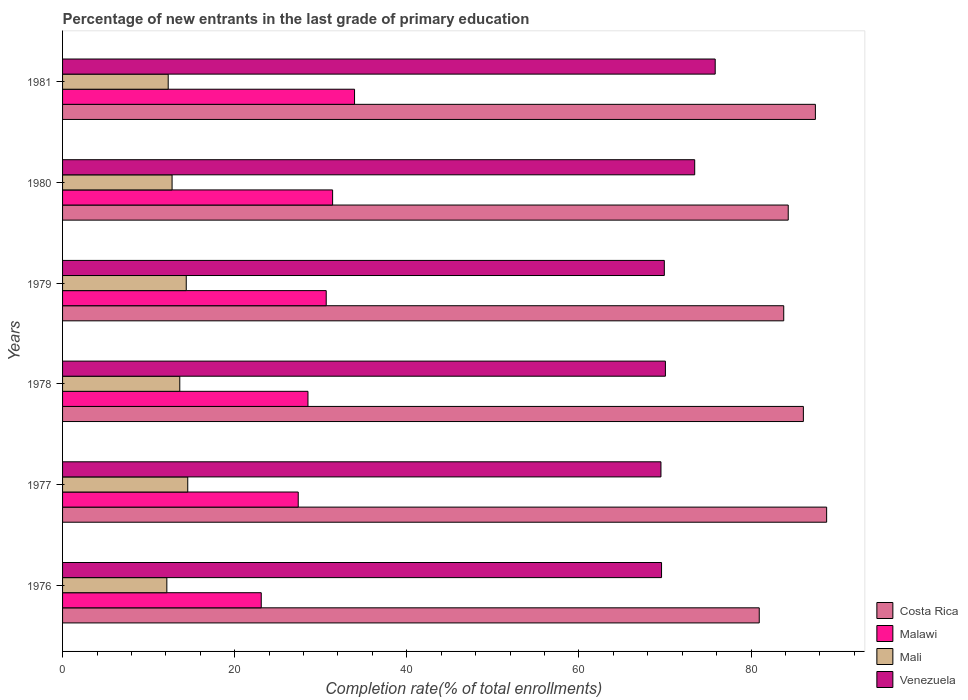How many groups of bars are there?
Offer a very short reply. 6. Are the number of bars on each tick of the Y-axis equal?
Provide a succinct answer. Yes. How many bars are there on the 2nd tick from the top?
Make the answer very short. 4. How many bars are there on the 4th tick from the bottom?
Your response must be concise. 4. What is the percentage of new entrants in Venezuela in 1981?
Offer a terse response. 75.83. Across all years, what is the maximum percentage of new entrants in Costa Rica?
Offer a very short reply. 88.77. Across all years, what is the minimum percentage of new entrants in Venezuela?
Ensure brevity in your answer.  69.52. In which year was the percentage of new entrants in Venezuela minimum?
Make the answer very short. 1977. What is the total percentage of new entrants in Costa Rica in the graph?
Offer a very short reply. 511.35. What is the difference between the percentage of new entrants in Mali in 1978 and that in 1979?
Your answer should be compact. -0.75. What is the difference between the percentage of new entrants in Malawi in 1980 and the percentage of new entrants in Mali in 1978?
Give a very brief answer. 17.76. What is the average percentage of new entrants in Malawi per year?
Provide a short and direct response. 29.15. In the year 1980, what is the difference between the percentage of new entrants in Costa Rica and percentage of new entrants in Malawi?
Your answer should be compact. 52.94. In how many years, is the percentage of new entrants in Mali greater than 48 %?
Provide a succinct answer. 0. What is the ratio of the percentage of new entrants in Mali in 1979 to that in 1980?
Keep it short and to the point. 1.13. What is the difference between the highest and the second highest percentage of new entrants in Venezuela?
Provide a short and direct response. 2.38. What is the difference between the highest and the lowest percentage of new entrants in Malawi?
Ensure brevity in your answer.  10.84. In how many years, is the percentage of new entrants in Costa Rica greater than the average percentage of new entrants in Costa Rica taken over all years?
Give a very brief answer. 3. Is the sum of the percentage of new entrants in Mali in 1977 and 1978 greater than the maximum percentage of new entrants in Venezuela across all years?
Your response must be concise. No. Is it the case that in every year, the sum of the percentage of new entrants in Venezuela and percentage of new entrants in Malawi is greater than the sum of percentage of new entrants in Mali and percentage of new entrants in Costa Rica?
Your response must be concise. Yes. What does the 3rd bar from the top in 1976 represents?
Offer a terse response. Malawi. What does the 3rd bar from the bottom in 1976 represents?
Provide a short and direct response. Mali. Is it the case that in every year, the sum of the percentage of new entrants in Costa Rica and percentage of new entrants in Malawi is greater than the percentage of new entrants in Mali?
Your answer should be compact. Yes. How many years are there in the graph?
Provide a succinct answer. 6. Are the values on the major ticks of X-axis written in scientific E-notation?
Your answer should be compact. No. Does the graph contain any zero values?
Your answer should be compact. No. How are the legend labels stacked?
Give a very brief answer. Vertical. What is the title of the graph?
Your answer should be very brief. Percentage of new entrants in the last grade of primary education. What is the label or title of the X-axis?
Give a very brief answer. Completion rate(% of total enrollments). What is the Completion rate(% of total enrollments) in Costa Rica in 1976?
Provide a short and direct response. 80.94. What is the Completion rate(% of total enrollments) of Malawi in 1976?
Provide a short and direct response. 23.08. What is the Completion rate(% of total enrollments) of Mali in 1976?
Give a very brief answer. 12.12. What is the Completion rate(% of total enrollments) in Venezuela in 1976?
Your response must be concise. 69.59. What is the Completion rate(% of total enrollments) of Costa Rica in 1977?
Your answer should be compact. 88.77. What is the Completion rate(% of total enrollments) of Malawi in 1977?
Provide a short and direct response. 27.38. What is the Completion rate(% of total enrollments) in Mali in 1977?
Offer a terse response. 14.55. What is the Completion rate(% of total enrollments) of Venezuela in 1977?
Your answer should be very brief. 69.52. What is the Completion rate(% of total enrollments) of Costa Rica in 1978?
Provide a succinct answer. 86.07. What is the Completion rate(% of total enrollments) in Malawi in 1978?
Offer a very short reply. 28.51. What is the Completion rate(% of total enrollments) of Mali in 1978?
Offer a very short reply. 13.62. What is the Completion rate(% of total enrollments) of Venezuela in 1978?
Your response must be concise. 70.04. What is the Completion rate(% of total enrollments) in Costa Rica in 1979?
Make the answer very short. 83.79. What is the Completion rate(% of total enrollments) of Malawi in 1979?
Your answer should be compact. 30.63. What is the Completion rate(% of total enrollments) in Mali in 1979?
Offer a terse response. 14.37. What is the Completion rate(% of total enrollments) in Venezuela in 1979?
Offer a very short reply. 69.91. What is the Completion rate(% of total enrollments) in Costa Rica in 1980?
Provide a short and direct response. 84.31. What is the Completion rate(% of total enrollments) of Malawi in 1980?
Give a very brief answer. 31.37. What is the Completion rate(% of total enrollments) in Mali in 1980?
Your answer should be compact. 12.72. What is the Completion rate(% of total enrollments) in Venezuela in 1980?
Make the answer very short. 73.44. What is the Completion rate(% of total enrollments) in Costa Rica in 1981?
Make the answer very short. 87.47. What is the Completion rate(% of total enrollments) in Malawi in 1981?
Offer a terse response. 33.92. What is the Completion rate(% of total enrollments) of Mali in 1981?
Offer a terse response. 12.27. What is the Completion rate(% of total enrollments) in Venezuela in 1981?
Make the answer very short. 75.83. Across all years, what is the maximum Completion rate(% of total enrollments) of Costa Rica?
Your answer should be very brief. 88.77. Across all years, what is the maximum Completion rate(% of total enrollments) of Malawi?
Make the answer very short. 33.92. Across all years, what is the maximum Completion rate(% of total enrollments) of Mali?
Provide a short and direct response. 14.55. Across all years, what is the maximum Completion rate(% of total enrollments) of Venezuela?
Offer a terse response. 75.83. Across all years, what is the minimum Completion rate(% of total enrollments) in Costa Rica?
Your answer should be very brief. 80.94. Across all years, what is the minimum Completion rate(% of total enrollments) of Malawi?
Your response must be concise. 23.08. Across all years, what is the minimum Completion rate(% of total enrollments) in Mali?
Give a very brief answer. 12.12. Across all years, what is the minimum Completion rate(% of total enrollments) of Venezuela?
Make the answer very short. 69.52. What is the total Completion rate(% of total enrollments) in Costa Rica in the graph?
Your response must be concise. 511.35. What is the total Completion rate(% of total enrollments) in Malawi in the graph?
Offer a very short reply. 174.91. What is the total Completion rate(% of total enrollments) of Mali in the graph?
Keep it short and to the point. 79.64. What is the total Completion rate(% of total enrollments) in Venezuela in the graph?
Ensure brevity in your answer.  428.34. What is the difference between the Completion rate(% of total enrollments) of Costa Rica in 1976 and that in 1977?
Keep it short and to the point. -7.83. What is the difference between the Completion rate(% of total enrollments) of Malawi in 1976 and that in 1977?
Make the answer very short. -4.3. What is the difference between the Completion rate(% of total enrollments) of Mali in 1976 and that in 1977?
Your answer should be compact. -2.43. What is the difference between the Completion rate(% of total enrollments) of Venezuela in 1976 and that in 1977?
Provide a succinct answer. 0.07. What is the difference between the Completion rate(% of total enrollments) in Costa Rica in 1976 and that in 1978?
Provide a short and direct response. -5.13. What is the difference between the Completion rate(% of total enrollments) in Malawi in 1976 and that in 1978?
Keep it short and to the point. -5.43. What is the difference between the Completion rate(% of total enrollments) of Mali in 1976 and that in 1978?
Your answer should be very brief. -1.5. What is the difference between the Completion rate(% of total enrollments) in Venezuela in 1976 and that in 1978?
Provide a short and direct response. -0.45. What is the difference between the Completion rate(% of total enrollments) of Costa Rica in 1976 and that in 1979?
Your answer should be compact. -2.85. What is the difference between the Completion rate(% of total enrollments) in Malawi in 1976 and that in 1979?
Make the answer very short. -7.55. What is the difference between the Completion rate(% of total enrollments) of Mali in 1976 and that in 1979?
Offer a very short reply. -2.25. What is the difference between the Completion rate(% of total enrollments) in Venezuela in 1976 and that in 1979?
Your answer should be very brief. -0.32. What is the difference between the Completion rate(% of total enrollments) in Costa Rica in 1976 and that in 1980?
Provide a short and direct response. -3.37. What is the difference between the Completion rate(% of total enrollments) in Malawi in 1976 and that in 1980?
Ensure brevity in your answer.  -8.29. What is the difference between the Completion rate(% of total enrollments) in Mali in 1976 and that in 1980?
Give a very brief answer. -0.61. What is the difference between the Completion rate(% of total enrollments) in Venezuela in 1976 and that in 1980?
Give a very brief answer. -3.85. What is the difference between the Completion rate(% of total enrollments) in Costa Rica in 1976 and that in 1981?
Make the answer very short. -6.52. What is the difference between the Completion rate(% of total enrollments) in Malawi in 1976 and that in 1981?
Your answer should be compact. -10.84. What is the difference between the Completion rate(% of total enrollments) in Mali in 1976 and that in 1981?
Your answer should be compact. -0.16. What is the difference between the Completion rate(% of total enrollments) of Venezuela in 1976 and that in 1981?
Keep it short and to the point. -6.23. What is the difference between the Completion rate(% of total enrollments) of Costa Rica in 1977 and that in 1978?
Keep it short and to the point. 2.7. What is the difference between the Completion rate(% of total enrollments) in Malawi in 1977 and that in 1978?
Your answer should be compact. -1.13. What is the difference between the Completion rate(% of total enrollments) in Mali in 1977 and that in 1978?
Your response must be concise. 0.93. What is the difference between the Completion rate(% of total enrollments) of Venezuela in 1977 and that in 1978?
Offer a very short reply. -0.52. What is the difference between the Completion rate(% of total enrollments) in Costa Rica in 1977 and that in 1979?
Provide a short and direct response. 4.99. What is the difference between the Completion rate(% of total enrollments) in Malawi in 1977 and that in 1979?
Keep it short and to the point. -3.25. What is the difference between the Completion rate(% of total enrollments) in Mali in 1977 and that in 1979?
Your answer should be compact. 0.18. What is the difference between the Completion rate(% of total enrollments) in Venezuela in 1977 and that in 1979?
Provide a succinct answer. -0.39. What is the difference between the Completion rate(% of total enrollments) of Costa Rica in 1977 and that in 1980?
Offer a very short reply. 4.46. What is the difference between the Completion rate(% of total enrollments) in Malawi in 1977 and that in 1980?
Ensure brevity in your answer.  -3.99. What is the difference between the Completion rate(% of total enrollments) of Mali in 1977 and that in 1980?
Provide a short and direct response. 1.82. What is the difference between the Completion rate(% of total enrollments) in Venezuela in 1977 and that in 1980?
Keep it short and to the point. -3.92. What is the difference between the Completion rate(% of total enrollments) of Costa Rica in 1977 and that in 1981?
Make the answer very short. 1.31. What is the difference between the Completion rate(% of total enrollments) of Malawi in 1977 and that in 1981?
Offer a very short reply. -6.54. What is the difference between the Completion rate(% of total enrollments) of Mali in 1977 and that in 1981?
Your answer should be compact. 2.27. What is the difference between the Completion rate(% of total enrollments) of Venezuela in 1977 and that in 1981?
Your response must be concise. -6.3. What is the difference between the Completion rate(% of total enrollments) in Costa Rica in 1978 and that in 1979?
Keep it short and to the point. 2.28. What is the difference between the Completion rate(% of total enrollments) in Malawi in 1978 and that in 1979?
Ensure brevity in your answer.  -2.12. What is the difference between the Completion rate(% of total enrollments) in Mali in 1978 and that in 1979?
Ensure brevity in your answer.  -0.75. What is the difference between the Completion rate(% of total enrollments) in Venezuela in 1978 and that in 1979?
Your answer should be compact. 0.12. What is the difference between the Completion rate(% of total enrollments) in Costa Rica in 1978 and that in 1980?
Make the answer very short. 1.76. What is the difference between the Completion rate(% of total enrollments) in Malawi in 1978 and that in 1980?
Your response must be concise. -2.86. What is the difference between the Completion rate(% of total enrollments) of Mali in 1978 and that in 1980?
Offer a very short reply. 0.9. What is the difference between the Completion rate(% of total enrollments) of Venezuela in 1978 and that in 1980?
Your answer should be very brief. -3.4. What is the difference between the Completion rate(% of total enrollments) in Costa Rica in 1978 and that in 1981?
Offer a terse response. -1.4. What is the difference between the Completion rate(% of total enrollments) of Malawi in 1978 and that in 1981?
Give a very brief answer. -5.41. What is the difference between the Completion rate(% of total enrollments) in Mali in 1978 and that in 1981?
Give a very brief answer. 1.35. What is the difference between the Completion rate(% of total enrollments) in Venezuela in 1978 and that in 1981?
Ensure brevity in your answer.  -5.79. What is the difference between the Completion rate(% of total enrollments) in Costa Rica in 1979 and that in 1980?
Offer a terse response. -0.52. What is the difference between the Completion rate(% of total enrollments) of Malawi in 1979 and that in 1980?
Offer a terse response. -0.74. What is the difference between the Completion rate(% of total enrollments) in Mali in 1979 and that in 1980?
Make the answer very short. 1.65. What is the difference between the Completion rate(% of total enrollments) in Venezuela in 1979 and that in 1980?
Provide a short and direct response. -3.53. What is the difference between the Completion rate(% of total enrollments) of Costa Rica in 1979 and that in 1981?
Offer a terse response. -3.68. What is the difference between the Completion rate(% of total enrollments) in Malawi in 1979 and that in 1981?
Ensure brevity in your answer.  -3.29. What is the difference between the Completion rate(% of total enrollments) of Mali in 1979 and that in 1981?
Offer a terse response. 2.1. What is the difference between the Completion rate(% of total enrollments) of Venezuela in 1979 and that in 1981?
Provide a short and direct response. -5.91. What is the difference between the Completion rate(% of total enrollments) in Costa Rica in 1980 and that in 1981?
Offer a terse response. -3.16. What is the difference between the Completion rate(% of total enrollments) of Malawi in 1980 and that in 1981?
Keep it short and to the point. -2.55. What is the difference between the Completion rate(% of total enrollments) in Mali in 1980 and that in 1981?
Offer a very short reply. 0.45. What is the difference between the Completion rate(% of total enrollments) in Venezuela in 1980 and that in 1981?
Give a very brief answer. -2.38. What is the difference between the Completion rate(% of total enrollments) of Costa Rica in 1976 and the Completion rate(% of total enrollments) of Malawi in 1977?
Provide a succinct answer. 53.56. What is the difference between the Completion rate(% of total enrollments) of Costa Rica in 1976 and the Completion rate(% of total enrollments) of Mali in 1977?
Offer a terse response. 66.4. What is the difference between the Completion rate(% of total enrollments) of Costa Rica in 1976 and the Completion rate(% of total enrollments) of Venezuela in 1977?
Ensure brevity in your answer.  11.42. What is the difference between the Completion rate(% of total enrollments) in Malawi in 1976 and the Completion rate(% of total enrollments) in Mali in 1977?
Your response must be concise. 8.54. What is the difference between the Completion rate(% of total enrollments) in Malawi in 1976 and the Completion rate(% of total enrollments) in Venezuela in 1977?
Your response must be concise. -46.44. What is the difference between the Completion rate(% of total enrollments) in Mali in 1976 and the Completion rate(% of total enrollments) in Venezuela in 1977?
Provide a short and direct response. -57.41. What is the difference between the Completion rate(% of total enrollments) of Costa Rica in 1976 and the Completion rate(% of total enrollments) of Malawi in 1978?
Your answer should be compact. 52.43. What is the difference between the Completion rate(% of total enrollments) in Costa Rica in 1976 and the Completion rate(% of total enrollments) in Mali in 1978?
Your answer should be very brief. 67.32. What is the difference between the Completion rate(% of total enrollments) of Costa Rica in 1976 and the Completion rate(% of total enrollments) of Venezuela in 1978?
Make the answer very short. 10.9. What is the difference between the Completion rate(% of total enrollments) of Malawi in 1976 and the Completion rate(% of total enrollments) of Mali in 1978?
Make the answer very short. 9.46. What is the difference between the Completion rate(% of total enrollments) in Malawi in 1976 and the Completion rate(% of total enrollments) in Venezuela in 1978?
Provide a succinct answer. -46.96. What is the difference between the Completion rate(% of total enrollments) of Mali in 1976 and the Completion rate(% of total enrollments) of Venezuela in 1978?
Your answer should be very brief. -57.92. What is the difference between the Completion rate(% of total enrollments) of Costa Rica in 1976 and the Completion rate(% of total enrollments) of Malawi in 1979?
Provide a short and direct response. 50.31. What is the difference between the Completion rate(% of total enrollments) of Costa Rica in 1976 and the Completion rate(% of total enrollments) of Mali in 1979?
Offer a terse response. 66.57. What is the difference between the Completion rate(% of total enrollments) in Costa Rica in 1976 and the Completion rate(% of total enrollments) in Venezuela in 1979?
Provide a succinct answer. 11.03. What is the difference between the Completion rate(% of total enrollments) in Malawi in 1976 and the Completion rate(% of total enrollments) in Mali in 1979?
Offer a very short reply. 8.71. What is the difference between the Completion rate(% of total enrollments) of Malawi in 1976 and the Completion rate(% of total enrollments) of Venezuela in 1979?
Ensure brevity in your answer.  -46.83. What is the difference between the Completion rate(% of total enrollments) of Mali in 1976 and the Completion rate(% of total enrollments) of Venezuela in 1979?
Provide a short and direct response. -57.8. What is the difference between the Completion rate(% of total enrollments) of Costa Rica in 1976 and the Completion rate(% of total enrollments) of Malawi in 1980?
Keep it short and to the point. 49.57. What is the difference between the Completion rate(% of total enrollments) of Costa Rica in 1976 and the Completion rate(% of total enrollments) of Mali in 1980?
Offer a very short reply. 68.22. What is the difference between the Completion rate(% of total enrollments) of Costa Rica in 1976 and the Completion rate(% of total enrollments) of Venezuela in 1980?
Keep it short and to the point. 7.5. What is the difference between the Completion rate(% of total enrollments) of Malawi in 1976 and the Completion rate(% of total enrollments) of Mali in 1980?
Give a very brief answer. 10.36. What is the difference between the Completion rate(% of total enrollments) in Malawi in 1976 and the Completion rate(% of total enrollments) in Venezuela in 1980?
Make the answer very short. -50.36. What is the difference between the Completion rate(% of total enrollments) of Mali in 1976 and the Completion rate(% of total enrollments) of Venezuela in 1980?
Keep it short and to the point. -61.33. What is the difference between the Completion rate(% of total enrollments) in Costa Rica in 1976 and the Completion rate(% of total enrollments) in Malawi in 1981?
Offer a very short reply. 47.02. What is the difference between the Completion rate(% of total enrollments) of Costa Rica in 1976 and the Completion rate(% of total enrollments) of Mali in 1981?
Offer a very short reply. 68.67. What is the difference between the Completion rate(% of total enrollments) of Costa Rica in 1976 and the Completion rate(% of total enrollments) of Venezuela in 1981?
Make the answer very short. 5.12. What is the difference between the Completion rate(% of total enrollments) of Malawi in 1976 and the Completion rate(% of total enrollments) of Mali in 1981?
Provide a short and direct response. 10.81. What is the difference between the Completion rate(% of total enrollments) in Malawi in 1976 and the Completion rate(% of total enrollments) in Venezuela in 1981?
Your answer should be compact. -52.74. What is the difference between the Completion rate(% of total enrollments) in Mali in 1976 and the Completion rate(% of total enrollments) in Venezuela in 1981?
Offer a terse response. -63.71. What is the difference between the Completion rate(% of total enrollments) in Costa Rica in 1977 and the Completion rate(% of total enrollments) in Malawi in 1978?
Offer a terse response. 60.26. What is the difference between the Completion rate(% of total enrollments) in Costa Rica in 1977 and the Completion rate(% of total enrollments) in Mali in 1978?
Provide a succinct answer. 75.16. What is the difference between the Completion rate(% of total enrollments) of Costa Rica in 1977 and the Completion rate(% of total enrollments) of Venezuela in 1978?
Offer a terse response. 18.73. What is the difference between the Completion rate(% of total enrollments) in Malawi in 1977 and the Completion rate(% of total enrollments) in Mali in 1978?
Offer a very short reply. 13.76. What is the difference between the Completion rate(% of total enrollments) in Malawi in 1977 and the Completion rate(% of total enrollments) in Venezuela in 1978?
Ensure brevity in your answer.  -42.66. What is the difference between the Completion rate(% of total enrollments) in Mali in 1977 and the Completion rate(% of total enrollments) in Venezuela in 1978?
Make the answer very short. -55.49. What is the difference between the Completion rate(% of total enrollments) of Costa Rica in 1977 and the Completion rate(% of total enrollments) of Malawi in 1979?
Your answer should be very brief. 58.14. What is the difference between the Completion rate(% of total enrollments) of Costa Rica in 1977 and the Completion rate(% of total enrollments) of Mali in 1979?
Give a very brief answer. 74.4. What is the difference between the Completion rate(% of total enrollments) of Costa Rica in 1977 and the Completion rate(% of total enrollments) of Venezuela in 1979?
Offer a terse response. 18.86. What is the difference between the Completion rate(% of total enrollments) in Malawi in 1977 and the Completion rate(% of total enrollments) in Mali in 1979?
Give a very brief answer. 13.01. What is the difference between the Completion rate(% of total enrollments) of Malawi in 1977 and the Completion rate(% of total enrollments) of Venezuela in 1979?
Your response must be concise. -42.53. What is the difference between the Completion rate(% of total enrollments) of Mali in 1977 and the Completion rate(% of total enrollments) of Venezuela in 1979?
Make the answer very short. -55.37. What is the difference between the Completion rate(% of total enrollments) of Costa Rica in 1977 and the Completion rate(% of total enrollments) of Malawi in 1980?
Your response must be concise. 57.4. What is the difference between the Completion rate(% of total enrollments) of Costa Rica in 1977 and the Completion rate(% of total enrollments) of Mali in 1980?
Make the answer very short. 76.05. What is the difference between the Completion rate(% of total enrollments) in Costa Rica in 1977 and the Completion rate(% of total enrollments) in Venezuela in 1980?
Offer a terse response. 15.33. What is the difference between the Completion rate(% of total enrollments) of Malawi in 1977 and the Completion rate(% of total enrollments) of Mali in 1980?
Ensure brevity in your answer.  14.66. What is the difference between the Completion rate(% of total enrollments) in Malawi in 1977 and the Completion rate(% of total enrollments) in Venezuela in 1980?
Provide a short and direct response. -46.06. What is the difference between the Completion rate(% of total enrollments) in Mali in 1977 and the Completion rate(% of total enrollments) in Venezuela in 1980?
Your response must be concise. -58.9. What is the difference between the Completion rate(% of total enrollments) of Costa Rica in 1977 and the Completion rate(% of total enrollments) of Malawi in 1981?
Your answer should be very brief. 54.85. What is the difference between the Completion rate(% of total enrollments) of Costa Rica in 1977 and the Completion rate(% of total enrollments) of Mali in 1981?
Keep it short and to the point. 76.5. What is the difference between the Completion rate(% of total enrollments) in Costa Rica in 1977 and the Completion rate(% of total enrollments) in Venezuela in 1981?
Ensure brevity in your answer.  12.95. What is the difference between the Completion rate(% of total enrollments) of Malawi in 1977 and the Completion rate(% of total enrollments) of Mali in 1981?
Provide a short and direct response. 15.11. What is the difference between the Completion rate(% of total enrollments) in Malawi in 1977 and the Completion rate(% of total enrollments) in Venezuela in 1981?
Give a very brief answer. -48.44. What is the difference between the Completion rate(% of total enrollments) in Mali in 1977 and the Completion rate(% of total enrollments) in Venezuela in 1981?
Provide a short and direct response. -61.28. What is the difference between the Completion rate(% of total enrollments) of Costa Rica in 1978 and the Completion rate(% of total enrollments) of Malawi in 1979?
Offer a terse response. 55.44. What is the difference between the Completion rate(% of total enrollments) of Costa Rica in 1978 and the Completion rate(% of total enrollments) of Mali in 1979?
Provide a short and direct response. 71.7. What is the difference between the Completion rate(% of total enrollments) in Costa Rica in 1978 and the Completion rate(% of total enrollments) in Venezuela in 1979?
Keep it short and to the point. 16.16. What is the difference between the Completion rate(% of total enrollments) in Malawi in 1978 and the Completion rate(% of total enrollments) in Mali in 1979?
Offer a terse response. 14.14. What is the difference between the Completion rate(% of total enrollments) in Malawi in 1978 and the Completion rate(% of total enrollments) in Venezuela in 1979?
Keep it short and to the point. -41.4. What is the difference between the Completion rate(% of total enrollments) of Mali in 1978 and the Completion rate(% of total enrollments) of Venezuela in 1979?
Your answer should be compact. -56.3. What is the difference between the Completion rate(% of total enrollments) of Costa Rica in 1978 and the Completion rate(% of total enrollments) of Malawi in 1980?
Provide a short and direct response. 54.7. What is the difference between the Completion rate(% of total enrollments) in Costa Rica in 1978 and the Completion rate(% of total enrollments) in Mali in 1980?
Give a very brief answer. 73.35. What is the difference between the Completion rate(% of total enrollments) in Costa Rica in 1978 and the Completion rate(% of total enrollments) in Venezuela in 1980?
Ensure brevity in your answer.  12.63. What is the difference between the Completion rate(% of total enrollments) of Malawi in 1978 and the Completion rate(% of total enrollments) of Mali in 1980?
Your answer should be very brief. 15.79. What is the difference between the Completion rate(% of total enrollments) in Malawi in 1978 and the Completion rate(% of total enrollments) in Venezuela in 1980?
Offer a terse response. -44.93. What is the difference between the Completion rate(% of total enrollments) in Mali in 1978 and the Completion rate(% of total enrollments) in Venezuela in 1980?
Offer a terse response. -59.83. What is the difference between the Completion rate(% of total enrollments) in Costa Rica in 1978 and the Completion rate(% of total enrollments) in Malawi in 1981?
Give a very brief answer. 52.15. What is the difference between the Completion rate(% of total enrollments) of Costa Rica in 1978 and the Completion rate(% of total enrollments) of Mali in 1981?
Make the answer very short. 73.8. What is the difference between the Completion rate(% of total enrollments) in Costa Rica in 1978 and the Completion rate(% of total enrollments) in Venezuela in 1981?
Provide a succinct answer. 10.24. What is the difference between the Completion rate(% of total enrollments) of Malawi in 1978 and the Completion rate(% of total enrollments) of Mali in 1981?
Keep it short and to the point. 16.24. What is the difference between the Completion rate(% of total enrollments) in Malawi in 1978 and the Completion rate(% of total enrollments) in Venezuela in 1981?
Your answer should be compact. -47.31. What is the difference between the Completion rate(% of total enrollments) of Mali in 1978 and the Completion rate(% of total enrollments) of Venezuela in 1981?
Your answer should be very brief. -62.21. What is the difference between the Completion rate(% of total enrollments) in Costa Rica in 1979 and the Completion rate(% of total enrollments) in Malawi in 1980?
Give a very brief answer. 52.41. What is the difference between the Completion rate(% of total enrollments) in Costa Rica in 1979 and the Completion rate(% of total enrollments) in Mali in 1980?
Make the answer very short. 71.07. What is the difference between the Completion rate(% of total enrollments) of Costa Rica in 1979 and the Completion rate(% of total enrollments) of Venezuela in 1980?
Give a very brief answer. 10.34. What is the difference between the Completion rate(% of total enrollments) of Malawi in 1979 and the Completion rate(% of total enrollments) of Mali in 1980?
Keep it short and to the point. 17.91. What is the difference between the Completion rate(% of total enrollments) of Malawi in 1979 and the Completion rate(% of total enrollments) of Venezuela in 1980?
Provide a succinct answer. -42.81. What is the difference between the Completion rate(% of total enrollments) of Mali in 1979 and the Completion rate(% of total enrollments) of Venezuela in 1980?
Give a very brief answer. -59.07. What is the difference between the Completion rate(% of total enrollments) of Costa Rica in 1979 and the Completion rate(% of total enrollments) of Malawi in 1981?
Offer a very short reply. 49.86. What is the difference between the Completion rate(% of total enrollments) in Costa Rica in 1979 and the Completion rate(% of total enrollments) in Mali in 1981?
Your answer should be compact. 71.52. What is the difference between the Completion rate(% of total enrollments) of Costa Rica in 1979 and the Completion rate(% of total enrollments) of Venezuela in 1981?
Give a very brief answer. 7.96. What is the difference between the Completion rate(% of total enrollments) of Malawi in 1979 and the Completion rate(% of total enrollments) of Mali in 1981?
Offer a terse response. 18.36. What is the difference between the Completion rate(% of total enrollments) in Malawi in 1979 and the Completion rate(% of total enrollments) in Venezuela in 1981?
Offer a terse response. -45.19. What is the difference between the Completion rate(% of total enrollments) in Mali in 1979 and the Completion rate(% of total enrollments) in Venezuela in 1981?
Your answer should be very brief. -61.46. What is the difference between the Completion rate(% of total enrollments) of Costa Rica in 1980 and the Completion rate(% of total enrollments) of Malawi in 1981?
Your answer should be very brief. 50.39. What is the difference between the Completion rate(% of total enrollments) of Costa Rica in 1980 and the Completion rate(% of total enrollments) of Mali in 1981?
Offer a terse response. 72.04. What is the difference between the Completion rate(% of total enrollments) of Costa Rica in 1980 and the Completion rate(% of total enrollments) of Venezuela in 1981?
Give a very brief answer. 8.48. What is the difference between the Completion rate(% of total enrollments) of Malawi in 1980 and the Completion rate(% of total enrollments) of Mali in 1981?
Give a very brief answer. 19.1. What is the difference between the Completion rate(% of total enrollments) in Malawi in 1980 and the Completion rate(% of total enrollments) in Venezuela in 1981?
Your answer should be compact. -44.45. What is the difference between the Completion rate(% of total enrollments) of Mali in 1980 and the Completion rate(% of total enrollments) of Venezuela in 1981?
Provide a succinct answer. -63.1. What is the average Completion rate(% of total enrollments) in Costa Rica per year?
Your response must be concise. 85.23. What is the average Completion rate(% of total enrollments) in Malawi per year?
Your answer should be very brief. 29.15. What is the average Completion rate(% of total enrollments) of Mali per year?
Ensure brevity in your answer.  13.27. What is the average Completion rate(% of total enrollments) in Venezuela per year?
Keep it short and to the point. 71.39. In the year 1976, what is the difference between the Completion rate(% of total enrollments) of Costa Rica and Completion rate(% of total enrollments) of Malawi?
Offer a terse response. 57.86. In the year 1976, what is the difference between the Completion rate(% of total enrollments) in Costa Rica and Completion rate(% of total enrollments) in Mali?
Your answer should be very brief. 68.83. In the year 1976, what is the difference between the Completion rate(% of total enrollments) of Costa Rica and Completion rate(% of total enrollments) of Venezuela?
Your answer should be very brief. 11.35. In the year 1976, what is the difference between the Completion rate(% of total enrollments) of Malawi and Completion rate(% of total enrollments) of Mali?
Keep it short and to the point. 10.97. In the year 1976, what is the difference between the Completion rate(% of total enrollments) in Malawi and Completion rate(% of total enrollments) in Venezuela?
Provide a short and direct response. -46.51. In the year 1976, what is the difference between the Completion rate(% of total enrollments) of Mali and Completion rate(% of total enrollments) of Venezuela?
Ensure brevity in your answer.  -57.48. In the year 1977, what is the difference between the Completion rate(% of total enrollments) in Costa Rica and Completion rate(% of total enrollments) in Malawi?
Your answer should be very brief. 61.39. In the year 1977, what is the difference between the Completion rate(% of total enrollments) in Costa Rica and Completion rate(% of total enrollments) in Mali?
Offer a terse response. 74.23. In the year 1977, what is the difference between the Completion rate(% of total enrollments) of Costa Rica and Completion rate(% of total enrollments) of Venezuela?
Keep it short and to the point. 19.25. In the year 1977, what is the difference between the Completion rate(% of total enrollments) of Malawi and Completion rate(% of total enrollments) of Mali?
Your answer should be very brief. 12.84. In the year 1977, what is the difference between the Completion rate(% of total enrollments) of Malawi and Completion rate(% of total enrollments) of Venezuela?
Keep it short and to the point. -42.14. In the year 1977, what is the difference between the Completion rate(% of total enrollments) of Mali and Completion rate(% of total enrollments) of Venezuela?
Ensure brevity in your answer.  -54.98. In the year 1978, what is the difference between the Completion rate(% of total enrollments) of Costa Rica and Completion rate(% of total enrollments) of Malawi?
Your response must be concise. 57.56. In the year 1978, what is the difference between the Completion rate(% of total enrollments) of Costa Rica and Completion rate(% of total enrollments) of Mali?
Provide a succinct answer. 72.45. In the year 1978, what is the difference between the Completion rate(% of total enrollments) of Costa Rica and Completion rate(% of total enrollments) of Venezuela?
Your response must be concise. 16.03. In the year 1978, what is the difference between the Completion rate(% of total enrollments) in Malawi and Completion rate(% of total enrollments) in Mali?
Your answer should be very brief. 14.89. In the year 1978, what is the difference between the Completion rate(% of total enrollments) in Malawi and Completion rate(% of total enrollments) in Venezuela?
Your response must be concise. -41.53. In the year 1978, what is the difference between the Completion rate(% of total enrollments) in Mali and Completion rate(% of total enrollments) in Venezuela?
Give a very brief answer. -56.42. In the year 1979, what is the difference between the Completion rate(% of total enrollments) in Costa Rica and Completion rate(% of total enrollments) in Malawi?
Your response must be concise. 53.16. In the year 1979, what is the difference between the Completion rate(% of total enrollments) of Costa Rica and Completion rate(% of total enrollments) of Mali?
Provide a short and direct response. 69.42. In the year 1979, what is the difference between the Completion rate(% of total enrollments) of Costa Rica and Completion rate(% of total enrollments) of Venezuela?
Provide a succinct answer. 13.87. In the year 1979, what is the difference between the Completion rate(% of total enrollments) of Malawi and Completion rate(% of total enrollments) of Mali?
Keep it short and to the point. 16.26. In the year 1979, what is the difference between the Completion rate(% of total enrollments) of Malawi and Completion rate(% of total enrollments) of Venezuela?
Provide a short and direct response. -39.28. In the year 1979, what is the difference between the Completion rate(% of total enrollments) in Mali and Completion rate(% of total enrollments) in Venezuela?
Your response must be concise. -55.55. In the year 1980, what is the difference between the Completion rate(% of total enrollments) in Costa Rica and Completion rate(% of total enrollments) in Malawi?
Offer a very short reply. 52.94. In the year 1980, what is the difference between the Completion rate(% of total enrollments) of Costa Rica and Completion rate(% of total enrollments) of Mali?
Provide a short and direct response. 71.59. In the year 1980, what is the difference between the Completion rate(% of total enrollments) in Costa Rica and Completion rate(% of total enrollments) in Venezuela?
Ensure brevity in your answer.  10.87. In the year 1980, what is the difference between the Completion rate(% of total enrollments) of Malawi and Completion rate(% of total enrollments) of Mali?
Provide a succinct answer. 18.65. In the year 1980, what is the difference between the Completion rate(% of total enrollments) in Malawi and Completion rate(% of total enrollments) in Venezuela?
Provide a succinct answer. -42.07. In the year 1980, what is the difference between the Completion rate(% of total enrollments) in Mali and Completion rate(% of total enrollments) in Venezuela?
Provide a succinct answer. -60.72. In the year 1981, what is the difference between the Completion rate(% of total enrollments) of Costa Rica and Completion rate(% of total enrollments) of Malawi?
Offer a terse response. 53.54. In the year 1981, what is the difference between the Completion rate(% of total enrollments) of Costa Rica and Completion rate(% of total enrollments) of Mali?
Make the answer very short. 75.19. In the year 1981, what is the difference between the Completion rate(% of total enrollments) in Costa Rica and Completion rate(% of total enrollments) in Venezuela?
Provide a succinct answer. 11.64. In the year 1981, what is the difference between the Completion rate(% of total enrollments) in Malawi and Completion rate(% of total enrollments) in Mali?
Make the answer very short. 21.65. In the year 1981, what is the difference between the Completion rate(% of total enrollments) in Malawi and Completion rate(% of total enrollments) in Venezuela?
Make the answer very short. -41.9. In the year 1981, what is the difference between the Completion rate(% of total enrollments) in Mali and Completion rate(% of total enrollments) in Venezuela?
Offer a very short reply. -63.55. What is the ratio of the Completion rate(% of total enrollments) in Costa Rica in 1976 to that in 1977?
Ensure brevity in your answer.  0.91. What is the ratio of the Completion rate(% of total enrollments) of Malawi in 1976 to that in 1977?
Your answer should be very brief. 0.84. What is the ratio of the Completion rate(% of total enrollments) of Mali in 1976 to that in 1977?
Make the answer very short. 0.83. What is the ratio of the Completion rate(% of total enrollments) of Costa Rica in 1976 to that in 1978?
Provide a succinct answer. 0.94. What is the ratio of the Completion rate(% of total enrollments) of Malawi in 1976 to that in 1978?
Offer a very short reply. 0.81. What is the ratio of the Completion rate(% of total enrollments) in Mali in 1976 to that in 1978?
Your response must be concise. 0.89. What is the ratio of the Completion rate(% of total enrollments) in Costa Rica in 1976 to that in 1979?
Ensure brevity in your answer.  0.97. What is the ratio of the Completion rate(% of total enrollments) of Malawi in 1976 to that in 1979?
Offer a very short reply. 0.75. What is the ratio of the Completion rate(% of total enrollments) in Mali in 1976 to that in 1979?
Offer a terse response. 0.84. What is the ratio of the Completion rate(% of total enrollments) of Venezuela in 1976 to that in 1979?
Provide a succinct answer. 1. What is the ratio of the Completion rate(% of total enrollments) in Costa Rica in 1976 to that in 1980?
Offer a very short reply. 0.96. What is the ratio of the Completion rate(% of total enrollments) of Malawi in 1976 to that in 1980?
Offer a terse response. 0.74. What is the ratio of the Completion rate(% of total enrollments) in Mali in 1976 to that in 1980?
Give a very brief answer. 0.95. What is the ratio of the Completion rate(% of total enrollments) of Venezuela in 1976 to that in 1980?
Offer a terse response. 0.95. What is the ratio of the Completion rate(% of total enrollments) of Costa Rica in 1976 to that in 1981?
Your answer should be compact. 0.93. What is the ratio of the Completion rate(% of total enrollments) of Malawi in 1976 to that in 1981?
Keep it short and to the point. 0.68. What is the ratio of the Completion rate(% of total enrollments) in Mali in 1976 to that in 1981?
Your response must be concise. 0.99. What is the ratio of the Completion rate(% of total enrollments) of Venezuela in 1976 to that in 1981?
Offer a very short reply. 0.92. What is the ratio of the Completion rate(% of total enrollments) of Costa Rica in 1977 to that in 1978?
Offer a very short reply. 1.03. What is the ratio of the Completion rate(% of total enrollments) in Malawi in 1977 to that in 1978?
Your answer should be very brief. 0.96. What is the ratio of the Completion rate(% of total enrollments) in Mali in 1977 to that in 1978?
Ensure brevity in your answer.  1.07. What is the ratio of the Completion rate(% of total enrollments) in Venezuela in 1977 to that in 1978?
Provide a short and direct response. 0.99. What is the ratio of the Completion rate(% of total enrollments) of Costa Rica in 1977 to that in 1979?
Your answer should be very brief. 1.06. What is the ratio of the Completion rate(% of total enrollments) of Malawi in 1977 to that in 1979?
Keep it short and to the point. 0.89. What is the ratio of the Completion rate(% of total enrollments) of Mali in 1977 to that in 1979?
Provide a short and direct response. 1.01. What is the ratio of the Completion rate(% of total enrollments) of Venezuela in 1977 to that in 1979?
Provide a succinct answer. 0.99. What is the ratio of the Completion rate(% of total enrollments) of Costa Rica in 1977 to that in 1980?
Give a very brief answer. 1.05. What is the ratio of the Completion rate(% of total enrollments) in Malawi in 1977 to that in 1980?
Provide a succinct answer. 0.87. What is the ratio of the Completion rate(% of total enrollments) of Mali in 1977 to that in 1980?
Your answer should be compact. 1.14. What is the ratio of the Completion rate(% of total enrollments) in Venezuela in 1977 to that in 1980?
Your response must be concise. 0.95. What is the ratio of the Completion rate(% of total enrollments) of Malawi in 1977 to that in 1981?
Your answer should be compact. 0.81. What is the ratio of the Completion rate(% of total enrollments) in Mali in 1977 to that in 1981?
Ensure brevity in your answer.  1.19. What is the ratio of the Completion rate(% of total enrollments) in Venezuela in 1977 to that in 1981?
Offer a very short reply. 0.92. What is the ratio of the Completion rate(% of total enrollments) of Costa Rica in 1978 to that in 1979?
Offer a very short reply. 1.03. What is the ratio of the Completion rate(% of total enrollments) in Malawi in 1978 to that in 1979?
Make the answer very short. 0.93. What is the ratio of the Completion rate(% of total enrollments) in Mali in 1978 to that in 1979?
Give a very brief answer. 0.95. What is the ratio of the Completion rate(% of total enrollments) in Costa Rica in 1978 to that in 1980?
Your answer should be very brief. 1.02. What is the ratio of the Completion rate(% of total enrollments) of Malawi in 1978 to that in 1980?
Keep it short and to the point. 0.91. What is the ratio of the Completion rate(% of total enrollments) of Mali in 1978 to that in 1980?
Ensure brevity in your answer.  1.07. What is the ratio of the Completion rate(% of total enrollments) in Venezuela in 1978 to that in 1980?
Give a very brief answer. 0.95. What is the ratio of the Completion rate(% of total enrollments) of Costa Rica in 1978 to that in 1981?
Provide a short and direct response. 0.98. What is the ratio of the Completion rate(% of total enrollments) in Malawi in 1978 to that in 1981?
Offer a very short reply. 0.84. What is the ratio of the Completion rate(% of total enrollments) in Mali in 1978 to that in 1981?
Your answer should be very brief. 1.11. What is the ratio of the Completion rate(% of total enrollments) in Venezuela in 1978 to that in 1981?
Your answer should be very brief. 0.92. What is the ratio of the Completion rate(% of total enrollments) in Malawi in 1979 to that in 1980?
Offer a terse response. 0.98. What is the ratio of the Completion rate(% of total enrollments) of Mali in 1979 to that in 1980?
Give a very brief answer. 1.13. What is the ratio of the Completion rate(% of total enrollments) of Venezuela in 1979 to that in 1980?
Your response must be concise. 0.95. What is the ratio of the Completion rate(% of total enrollments) of Costa Rica in 1979 to that in 1981?
Offer a terse response. 0.96. What is the ratio of the Completion rate(% of total enrollments) of Malawi in 1979 to that in 1981?
Keep it short and to the point. 0.9. What is the ratio of the Completion rate(% of total enrollments) of Mali in 1979 to that in 1981?
Make the answer very short. 1.17. What is the ratio of the Completion rate(% of total enrollments) of Venezuela in 1979 to that in 1981?
Keep it short and to the point. 0.92. What is the ratio of the Completion rate(% of total enrollments) in Costa Rica in 1980 to that in 1981?
Provide a short and direct response. 0.96. What is the ratio of the Completion rate(% of total enrollments) of Malawi in 1980 to that in 1981?
Provide a short and direct response. 0.92. What is the ratio of the Completion rate(% of total enrollments) in Mali in 1980 to that in 1981?
Offer a very short reply. 1.04. What is the ratio of the Completion rate(% of total enrollments) of Venezuela in 1980 to that in 1981?
Your response must be concise. 0.97. What is the difference between the highest and the second highest Completion rate(% of total enrollments) of Costa Rica?
Your answer should be very brief. 1.31. What is the difference between the highest and the second highest Completion rate(% of total enrollments) in Malawi?
Provide a succinct answer. 2.55. What is the difference between the highest and the second highest Completion rate(% of total enrollments) of Mali?
Provide a succinct answer. 0.18. What is the difference between the highest and the second highest Completion rate(% of total enrollments) of Venezuela?
Provide a succinct answer. 2.38. What is the difference between the highest and the lowest Completion rate(% of total enrollments) in Costa Rica?
Your answer should be very brief. 7.83. What is the difference between the highest and the lowest Completion rate(% of total enrollments) in Malawi?
Keep it short and to the point. 10.84. What is the difference between the highest and the lowest Completion rate(% of total enrollments) of Mali?
Provide a short and direct response. 2.43. What is the difference between the highest and the lowest Completion rate(% of total enrollments) in Venezuela?
Provide a succinct answer. 6.3. 